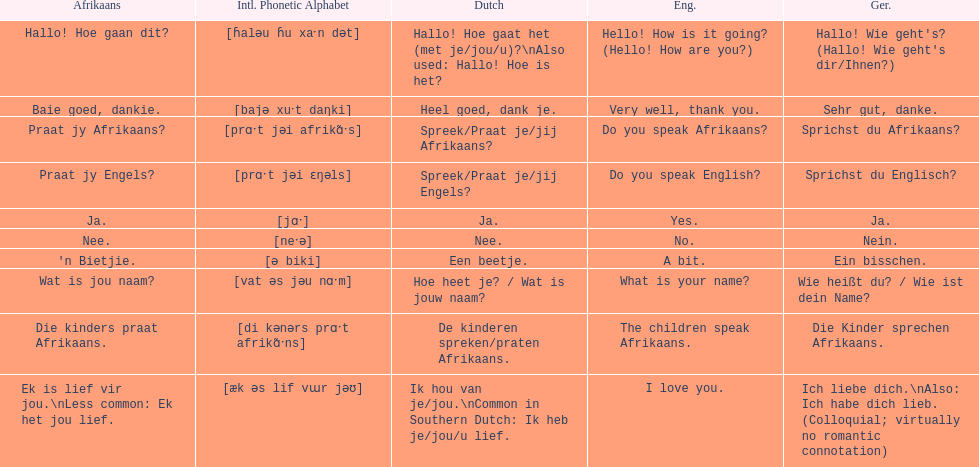Can you provide the english translation for 'n bietjie? A bit. 